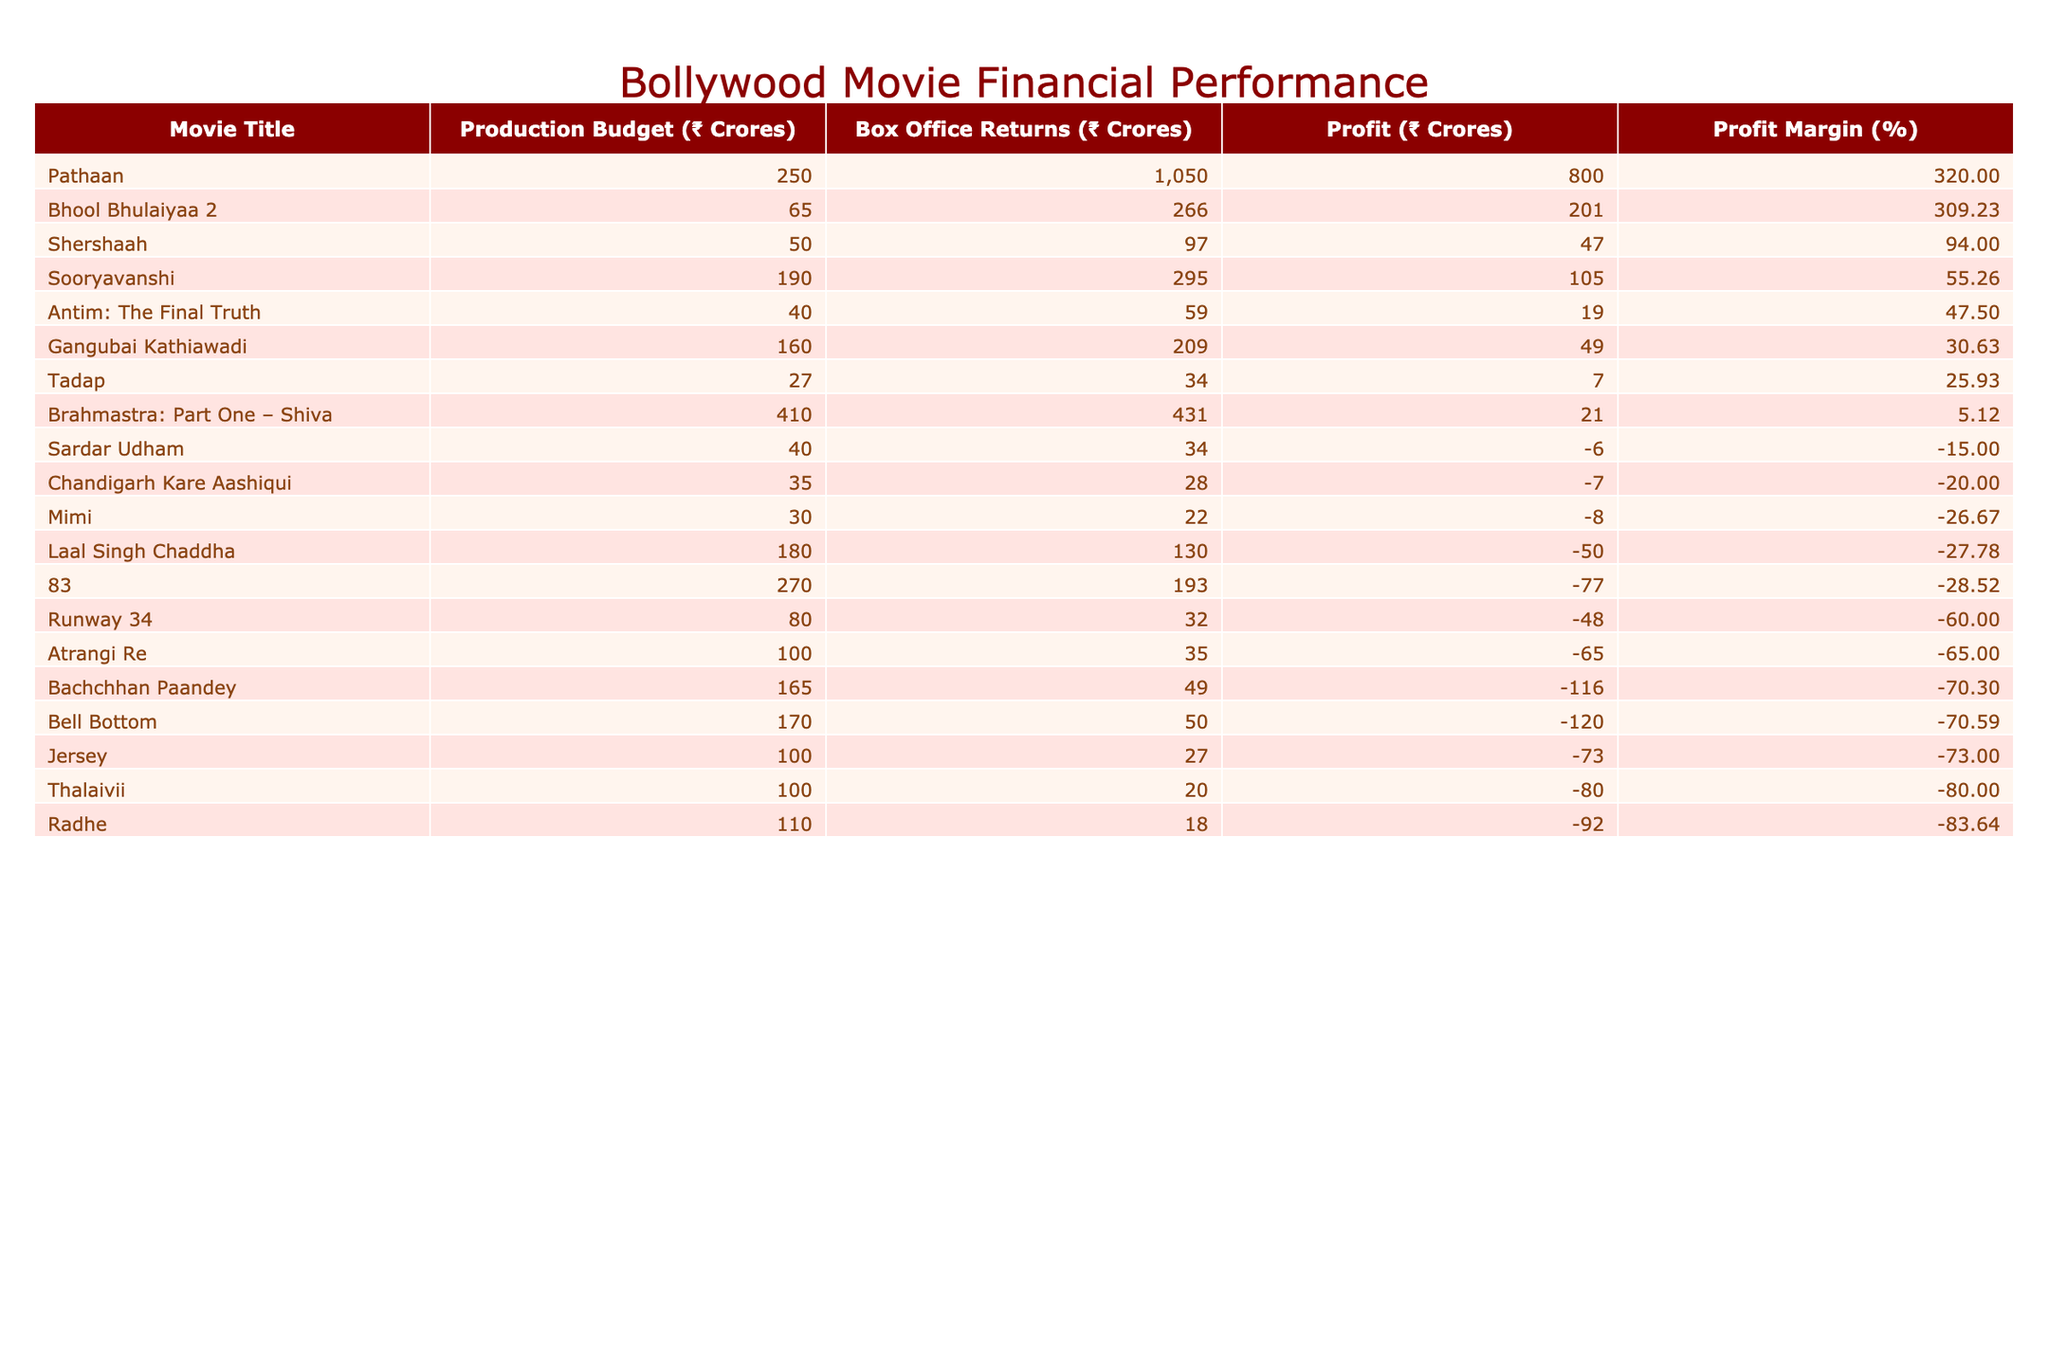What is the production budget of the movie "Pathaan"? The table directly lists the production budget of "Pathaan" as ₹250 Crores under the column for Production Budget.
Answer: ₹250 Crores Which movie had the highest box office returns? "Pathaan" shows the highest box office returns at ₹1050 Crores in the table.
Answer: "Pathaan" What was the profit margin of "Gangubai Kathiawadi"? The profit margin is calculated as (Box Office Returns - Production Budget) / Production Budget × 100. For "Gangubai Kathiawadi," it is (209 - 160) / 160 × 100 = 30.62%.
Answer: 30.62% Is the production budget of "Brahmastra: Part One – Shiva" greater than ₹400 Crores? The production budget listed for "Brahmastra: Part One – Shiva" is ₹410 Crores, which is indeed greater than ₹400 Crores.
Answer: Yes What is the total profit of "Jersey"? The profit is calculated as Box Office Returns - Production Budget = 27 - 100 = -73 Crores, indicating a loss.
Answer: -₹73 Crores Which movie had the lowest box office returns among those listed? The table shows that "Radhe" had the lowest box office returns at ₹18 Crores, which is less than all other movies' returns.
Answer: "Radhe" What is the difference between the box office returns of "Sooryavanshi" and "Laal Singh Chaddha"? The box office returns are ₹295 Crores for "Sooryavanshi" and ₹130 Crores for "Laal Singh Chaddha". The difference is 295 - 130 = ₹165 Crores.
Answer: ₹165 Crores How many movies generated a profit of at least ₹100 Crores? By examining the profit values, only "Pathaan" and "Bhool Bhulaiyaa 2" had a profit of at least ₹100 Crores. "Pathaan" had a profit of ₹800 Crores and "Bhool Bhulaiyaa 2" had a profit of ₹201 Crores.
Answer: 2 What is the average production budget of the movies listed? The total production budget is 250 + 410 + 180 + 160 + 270 + 190 + 65 + 27 + 165 + 100 + 80 + 35 + 170 + 110 + 100 + 50 + 100 + 30 + 40 + 40 = ₹1851 Crores, and there are 20 movies, so the average is 1851 / 20 = ₹92.55 Crores.
Answer: ₹92.55 Crores Which movie has a profit margin closest to 25%? The profit margin calculations show that "Sooryavanshi" has a profit margin of 55.26%, while "Jersey" has -73% and others fall above or below 25%. The closest margins listed below 25% are "Radhe" at -13.64% and "Thalaivii" at 20% suggesting that no movie is directly at 25%.
Answer: No movie at 25% margin 